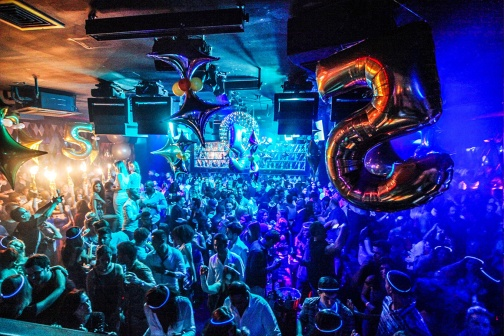What kind of music do you think is playing at this party? Given the lively and celebratory atmosphere depicted in the image, the music at this party is likely energetic and upbeat, perhaps a mix of popular dance hits, electronic beats, and classic party anthems. The DJ could be blending these tracks seamlessly, keeping the crowd moving and the energy high throughout the night. What's happening at the edges of the crowd? At the edges of the crowd, smaller groups of people are engaged in conversations and laughter. Some are taking brief breaks from dancing, sipping their drinks, and catching their breath while others take photos to capture the memories of the night. The bar staff is busy serving drinks to those who step away from the dance floor, and the ambient lighting creates cozy spots for more intimate or quieter interactions. Imagine the party is underwater. Describe it. In an otherworldly underwater version of the party, the nightclub is submerged beneath a crystal-clear ocean. The lighting is soft and refracted through the water, creating an ethereal glow. Marine life glides gracefully around, adding to the magical atmosphere. Bubbles rise from the guests as they dance on a transparent floor that gives a stunning view of the ocean depths. The bar serves drinks in luminous, pearl-like shells, and coral decorations add to the enchantment. The music is transformed into a harmonic blend that resonates through the water, making the entire experience surreal and mesmerizing. What's a funny moment that could happen at this party? A funny moment might involve a group of friends attempting to surprise the birthday person with a giant cake. As they approach, one of them trips and causes a slight chain reaction of near-falls and laughter. In the confusion, the birthday person ends up covered in a small bit of frosting, leading to a playful and laughter-filled cake fight among friends that lightens the mood even further. In a realistic scenario, how might the event wind down? As the night progresses, the energy begins to mellow, with some guests heading home. The dance floor, still active, sees slower dances while others gather in small groups, recounting their favorite moments of the night. The bartenders start cleaning up and organizing, signaling the end of the service. As the lights gradually brighten, goodbyes are said, and people leave with smiles, carrying with them memories of a fantastic celebration. How about a short glimpse of the next morning at the club? The next morning, the nightclub looks vastly different. Sunlight filters in through high windows, illuminating the remnants of the night's festivities. Balloons that once floated high are now partly deflated on the floor. The bar is quiet, with empty glasses and bottles scattered around. A few staff members are already at work, meticulously cleaning and restoring the space to its pre-party state, ready to transform it once again for the next event. 